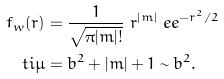Convert formula to latex. <formula><loc_0><loc_0><loc_500><loc_500>f _ { w } ( r ) & = \frac { 1 } { \sqrt { \pi | m | ! } } \ r ^ { | m | } \ e e ^ { - r ^ { 2 } / 2 } \\ \ t i { \mu } & = b ^ { 2 } + | m | + 1 \sim b ^ { 2 } .</formula> 